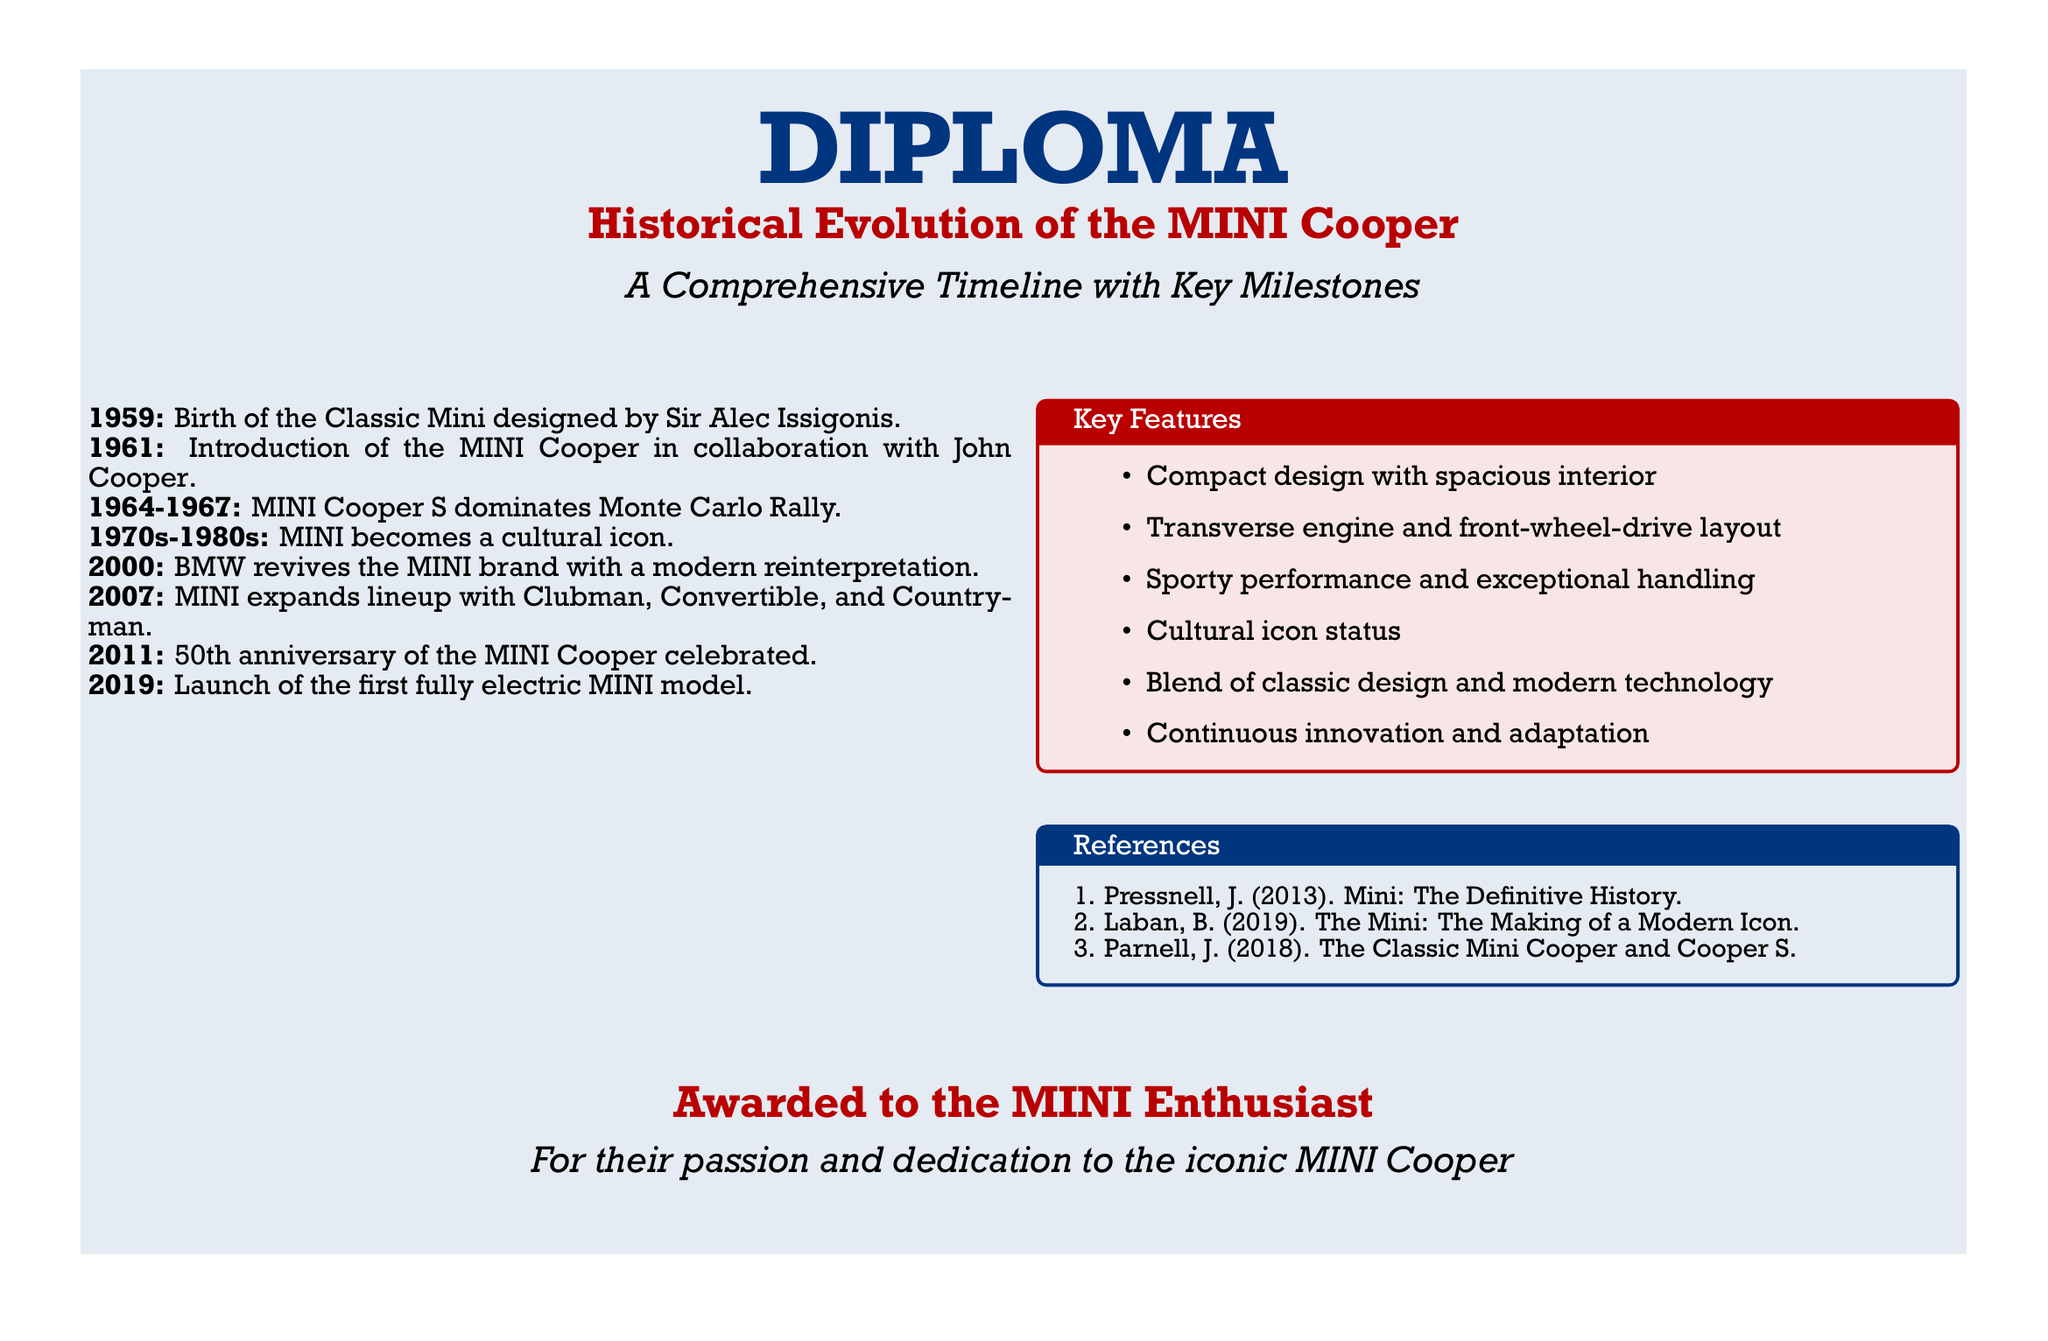What year was the MINI Cooper first introduced? The document states that the MINI Cooper was introduced in 1961.
Answer: 1961 Who designed the Classic Mini? According to the document, the Classic Mini was designed by Sir Alec Issigonis.
Answer: Sir Alec Issigonis What significant event did the MINI Cooper S dominate? The document mentions that the MINI Cooper S dominated the Monte Carlo Rally from 1964 to 1967.
Answer: Monte Carlo Rally In what year did BMW revive the MINI brand? The document notes that BMW revived the MINI brand in 2000.
Answer: 2000 How many key features are listed in the document? The document contains a list of six key features of the MINI Cooper.
Answer: Six What anniversary of the MINI Cooper was celebrated in 2011? According to the document, the 50th anniversary of the MINI Cooper was celebrated in 2011.
Answer: 50th anniversary Which model was the first fully electric MINI launched? The document specifies that the first fully electric MINI model was launched in 2019.
Answer: 2019 What color is the diploma background? The document describes the diploma background color as white.
Answer: White What is the title of the diploma? The document states the title of the diploma is "Historical Evolution of the MINI Cooper."
Answer: Historical Evolution of the MINI Cooper Who is the diploma awarded to? According to the document, the diploma is awarded to the MINI Enthusiast.
Answer: MINI Enthusiast 